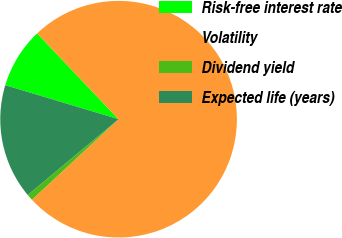<chart> <loc_0><loc_0><loc_500><loc_500><pie_chart><fcel>Risk-free interest rate<fcel>Volatility<fcel>Dividend yield<fcel>Expected life (years)<nl><fcel>8.28%<fcel>75.16%<fcel>0.85%<fcel>15.71%<nl></chart> 